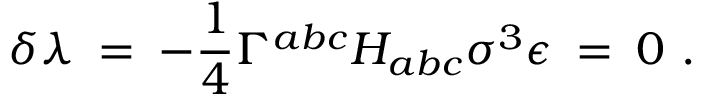Convert formula to latex. <formula><loc_0><loc_0><loc_500><loc_500>\delta \lambda \, = \, - \frac { 1 } { 4 } \Gamma ^ { a b c } H _ { a b c } \sigma ^ { 3 } \epsilon \, = \, 0 \ .</formula> 